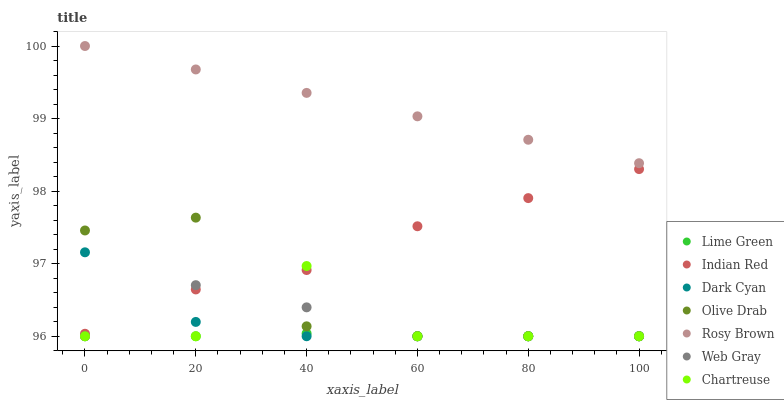Does Lime Green have the minimum area under the curve?
Answer yes or no. Yes. Does Rosy Brown have the maximum area under the curve?
Answer yes or no. Yes. Does Chartreuse have the minimum area under the curve?
Answer yes or no. No. Does Chartreuse have the maximum area under the curve?
Answer yes or no. No. Is Rosy Brown the smoothest?
Answer yes or no. Yes. Is Chartreuse the roughest?
Answer yes or no. Yes. Is Chartreuse the smoothest?
Answer yes or no. No. Is Rosy Brown the roughest?
Answer yes or no. No. Does Web Gray have the lowest value?
Answer yes or no. Yes. Does Rosy Brown have the lowest value?
Answer yes or no. No. Does Rosy Brown have the highest value?
Answer yes or no. Yes. Does Chartreuse have the highest value?
Answer yes or no. No. Is Dark Cyan less than Rosy Brown?
Answer yes or no. Yes. Is Rosy Brown greater than Indian Red?
Answer yes or no. Yes. Does Lime Green intersect Web Gray?
Answer yes or no. Yes. Is Lime Green less than Web Gray?
Answer yes or no. No. Is Lime Green greater than Web Gray?
Answer yes or no. No. Does Dark Cyan intersect Rosy Brown?
Answer yes or no. No. 